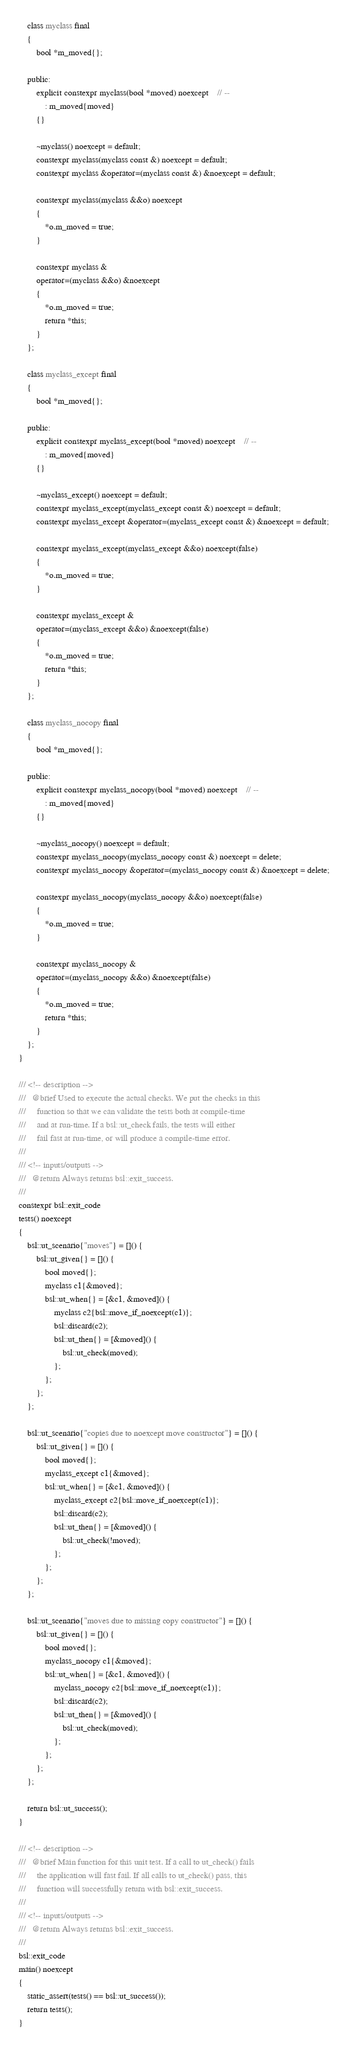<code> <loc_0><loc_0><loc_500><loc_500><_C++_>    class myclass final
    {
        bool *m_moved{};

    public:
        explicit constexpr myclass(bool *moved) noexcept    // --
            : m_moved{moved}
        {}

        ~myclass() noexcept = default;
        constexpr myclass(myclass const &) noexcept = default;
        constexpr myclass &operator=(myclass const &) &noexcept = default;

        constexpr myclass(myclass &&o) noexcept
        {
            *o.m_moved = true;
        }

        constexpr myclass &
        operator=(myclass &&o) &noexcept
        {
            *o.m_moved = true;
            return *this;
        }
    };

    class myclass_except final
    {
        bool *m_moved{};

    public:
        explicit constexpr myclass_except(bool *moved) noexcept    // --
            : m_moved{moved}
        {}

        ~myclass_except() noexcept = default;
        constexpr myclass_except(myclass_except const &) noexcept = default;
        constexpr myclass_except &operator=(myclass_except const &) &noexcept = default;

        constexpr myclass_except(myclass_except &&o) noexcept(false)
        {
            *o.m_moved = true;
        }

        constexpr myclass_except &
        operator=(myclass_except &&o) &noexcept(false)
        {
            *o.m_moved = true;
            return *this;
        }
    };

    class myclass_nocopy final
    {
        bool *m_moved{};

    public:
        explicit constexpr myclass_nocopy(bool *moved) noexcept    // --
            : m_moved{moved}
        {}

        ~myclass_nocopy() noexcept = default;
        constexpr myclass_nocopy(myclass_nocopy const &) noexcept = delete;
        constexpr myclass_nocopy &operator=(myclass_nocopy const &) &noexcept = delete;

        constexpr myclass_nocopy(myclass_nocopy &&o) noexcept(false)
        {
            *o.m_moved = true;
        }

        constexpr myclass_nocopy &
        operator=(myclass_nocopy &&o) &noexcept(false)
        {
            *o.m_moved = true;
            return *this;
        }
    };
}

/// <!-- description -->
///   @brief Used to execute the actual checks. We put the checks in this
///     function so that we can validate the tests both at compile-time
///     and at run-time. If a bsl::ut_check fails, the tests will either
///     fail fast at run-time, or will produce a compile-time error.
///
/// <!-- inputs/outputs -->
///   @return Always returns bsl::exit_success.
///
constexpr bsl::exit_code
tests() noexcept
{
    bsl::ut_scenario{"moves"} = []() {
        bsl::ut_given{} = []() {
            bool moved{};
            myclass c1{&moved};
            bsl::ut_when{} = [&c1, &moved]() {
                myclass c2{bsl::move_if_noexcept(c1)};
                bsl::discard(c2);
                bsl::ut_then{} = [&moved]() {
                    bsl::ut_check(moved);
                };
            };
        };
    };

    bsl::ut_scenario{"copies due to noexcept move constructor"} = []() {
        bsl::ut_given{} = []() {
            bool moved{};
            myclass_except c1{&moved};
            bsl::ut_when{} = [&c1, &moved]() {
                myclass_except c2{bsl::move_if_noexcept(c1)};
                bsl::discard(c2);
                bsl::ut_then{} = [&moved]() {
                    bsl::ut_check(!moved);
                };
            };
        };
    };

    bsl::ut_scenario{"moves due to missing copy constructor"} = []() {
        bsl::ut_given{} = []() {
            bool moved{};
            myclass_nocopy c1{&moved};
            bsl::ut_when{} = [&c1, &moved]() {
                myclass_nocopy c2{bsl::move_if_noexcept(c1)};
                bsl::discard(c2);
                bsl::ut_then{} = [&moved]() {
                    bsl::ut_check(moved);
                };
            };
        };
    };

    return bsl::ut_success();
}

/// <!-- description -->
///   @brief Main function for this unit test. If a call to ut_check() fails
///     the application will fast fail. If all calls to ut_check() pass, this
///     function will successfully return with bsl::exit_success.
///
/// <!-- inputs/outputs -->
///   @return Always returns bsl::exit_success.
///
bsl::exit_code
main() noexcept
{
    static_assert(tests() == bsl::ut_success());
    return tests();
}
</code> 